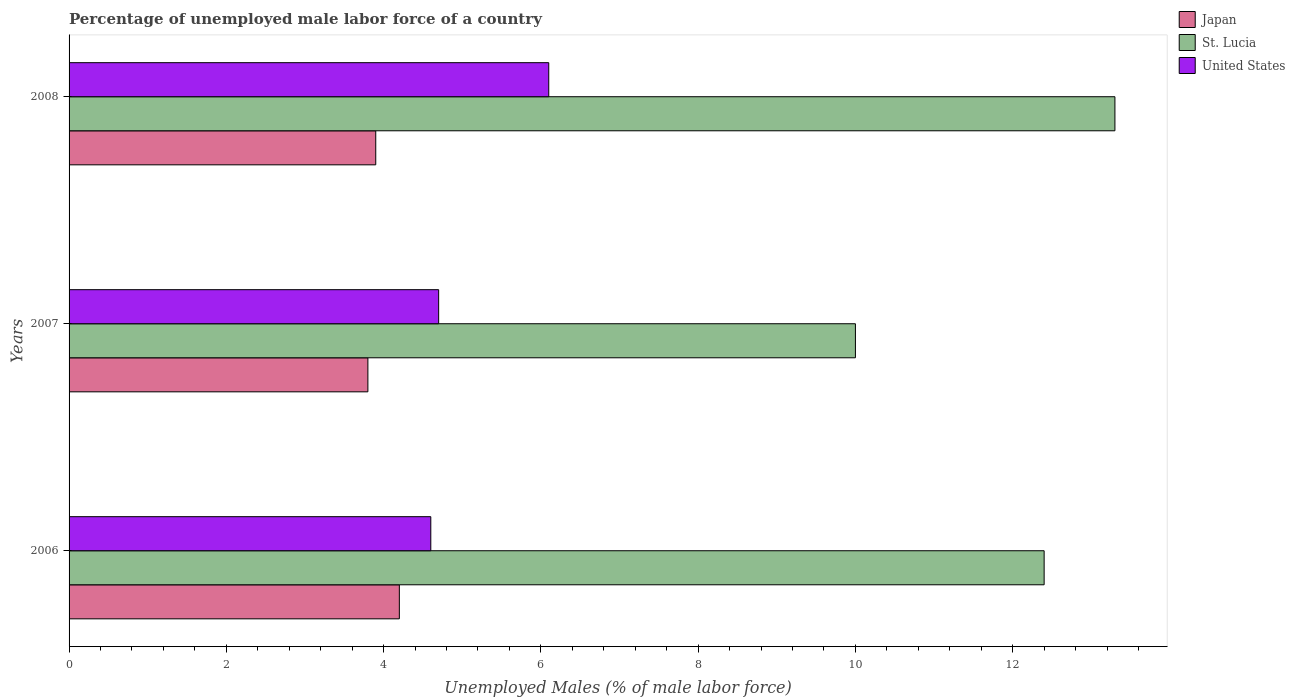How many different coloured bars are there?
Your response must be concise. 3. How many groups of bars are there?
Give a very brief answer. 3. Are the number of bars per tick equal to the number of legend labels?
Ensure brevity in your answer.  Yes. How many bars are there on the 2nd tick from the top?
Keep it short and to the point. 3. How many bars are there on the 2nd tick from the bottom?
Offer a very short reply. 3. What is the label of the 3rd group of bars from the top?
Keep it short and to the point. 2006. In how many cases, is the number of bars for a given year not equal to the number of legend labels?
Your answer should be compact. 0. Across all years, what is the maximum percentage of unemployed male labor force in Japan?
Ensure brevity in your answer.  4.2. Across all years, what is the minimum percentage of unemployed male labor force in United States?
Provide a succinct answer. 4.6. What is the total percentage of unemployed male labor force in United States in the graph?
Make the answer very short. 15.4. What is the difference between the percentage of unemployed male labor force in St. Lucia in 2007 and that in 2008?
Your response must be concise. -3.3. What is the difference between the percentage of unemployed male labor force in United States in 2006 and the percentage of unemployed male labor force in St. Lucia in 2007?
Offer a terse response. -5.4. What is the average percentage of unemployed male labor force in St. Lucia per year?
Provide a succinct answer. 11.9. In the year 2008, what is the difference between the percentage of unemployed male labor force in St. Lucia and percentage of unemployed male labor force in United States?
Your answer should be very brief. 7.2. What is the ratio of the percentage of unemployed male labor force in Japan in 2006 to that in 2008?
Provide a short and direct response. 1.08. What is the difference between the highest and the second highest percentage of unemployed male labor force in Japan?
Ensure brevity in your answer.  0.3. What is the difference between the highest and the lowest percentage of unemployed male labor force in St. Lucia?
Give a very brief answer. 3.3. In how many years, is the percentage of unemployed male labor force in St. Lucia greater than the average percentage of unemployed male labor force in St. Lucia taken over all years?
Ensure brevity in your answer.  2. What does the 2nd bar from the top in 2008 represents?
Make the answer very short. St. Lucia. What does the 1st bar from the bottom in 2006 represents?
Your answer should be very brief. Japan. Is it the case that in every year, the sum of the percentage of unemployed male labor force in Japan and percentage of unemployed male labor force in United States is greater than the percentage of unemployed male labor force in St. Lucia?
Your answer should be very brief. No. How many years are there in the graph?
Your response must be concise. 3. Are the values on the major ticks of X-axis written in scientific E-notation?
Offer a terse response. No. Does the graph contain any zero values?
Give a very brief answer. No. Where does the legend appear in the graph?
Offer a terse response. Top right. How many legend labels are there?
Your response must be concise. 3. What is the title of the graph?
Keep it short and to the point. Percentage of unemployed male labor force of a country. Does "Israel" appear as one of the legend labels in the graph?
Ensure brevity in your answer.  No. What is the label or title of the X-axis?
Make the answer very short. Unemployed Males (% of male labor force). What is the Unemployed Males (% of male labor force) of Japan in 2006?
Offer a very short reply. 4.2. What is the Unemployed Males (% of male labor force) in St. Lucia in 2006?
Provide a succinct answer. 12.4. What is the Unemployed Males (% of male labor force) in United States in 2006?
Provide a succinct answer. 4.6. What is the Unemployed Males (% of male labor force) of Japan in 2007?
Offer a terse response. 3.8. What is the Unemployed Males (% of male labor force) in St. Lucia in 2007?
Your answer should be compact. 10. What is the Unemployed Males (% of male labor force) of United States in 2007?
Provide a succinct answer. 4.7. What is the Unemployed Males (% of male labor force) of Japan in 2008?
Provide a short and direct response. 3.9. What is the Unemployed Males (% of male labor force) of St. Lucia in 2008?
Your answer should be very brief. 13.3. What is the Unemployed Males (% of male labor force) in United States in 2008?
Give a very brief answer. 6.1. Across all years, what is the maximum Unemployed Males (% of male labor force) of Japan?
Ensure brevity in your answer.  4.2. Across all years, what is the maximum Unemployed Males (% of male labor force) in St. Lucia?
Provide a succinct answer. 13.3. Across all years, what is the maximum Unemployed Males (% of male labor force) in United States?
Provide a succinct answer. 6.1. Across all years, what is the minimum Unemployed Males (% of male labor force) of Japan?
Make the answer very short. 3.8. Across all years, what is the minimum Unemployed Males (% of male labor force) of United States?
Give a very brief answer. 4.6. What is the total Unemployed Males (% of male labor force) of Japan in the graph?
Ensure brevity in your answer.  11.9. What is the total Unemployed Males (% of male labor force) of St. Lucia in the graph?
Your response must be concise. 35.7. What is the difference between the Unemployed Males (% of male labor force) of St. Lucia in 2006 and that in 2007?
Your answer should be compact. 2.4. What is the difference between the Unemployed Males (% of male labor force) in Japan in 2006 and that in 2008?
Your response must be concise. 0.3. What is the difference between the Unemployed Males (% of male labor force) of St. Lucia in 2007 and that in 2008?
Your answer should be compact. -3.3. What is the difference between the Unemployed Males (% of male labor force) of United States in 2007 and that in 2008?
Give a very brief answer. -1.4. What is the difference between the Unemployed Males (% of male labor force) in Japan in 2006 and the Unemployed Males (% of male labor force) in St. Lucia in 2008?
Your response must be concise. -9.1. What is the difference between the Unemployed Males (% of male labor force) of St. Lucia in 2006 and the Unemployed Males (% of male labor force) of United States in 2008?
Give a very brief answer. 6.3. What is the difference between the Unemployed Males (% of male labor force) in Japan in 2007 and the Unemployed Males (% of male labor force) in St. Lucia in 2008?
Make the answer very short. -9.5. What is the difference between the Unemployed Males (% of male labor force) in Japan in 2007 and the Unemployed Males (% of male labor force) in United States in 2008?
Your answer should be very brief. -2.3. What is the difference between the Unemployed Males (% of male labor force) in St. Lucia in 2007 and the Unemployed Males (% of male labor force) in United States in 2008?
Offer a very short reply. 3.9. What is the average Unemployed Males (% of male labor force) of Japan per year?
Your answer should be very brief. 3.97. What is the average Unemployed Males (% of male labor force) of St. Lucia per year?
Give a very brief answer. 11.9. What is the average Unemployed Males (% of male labor force) in United States per year?
Provide a short and direct response. 5.13. In the year 2006, what is the difference between the Unemployed Males (% of male labor force) of Japan and Unemployed Males (% of male labor force) of St. Lucia?
Offer a terse response. -8.2. In the year 2006, what is the difference between the Unemployed Males (% of male labor force) of Japan and Unemployed Males (% of male labor force) of United States?
Offer a very short reply. -0.4. In the year 2006, what is the difference between the Unemployed Males (% of male labor force) of St. Lucia and Unemployed Males (% of male labor force) of United States?
Offer a very short reply. 7.8. In the year 2008, what is the difference between the Unemployed Males (% of male labor force) in St. Lucia and Unemployed Males (% of male labor force) in United States?
Provide a short and direct response. 7.2. What is the ratio of the Unemployed Males (% of male labor force) of Japan in 2006 to that in 2007?
Your answer should be compact. 1.11. What is the ratio of the Unemployed Males (% of male labor force) of St. Lucia in 2006 to that in 2007?
Keep it short and to the point. 1.24. What is the ratio of the Unemployed Males (% of male labor force) of United States in 2006 to that in 2007?
Provide a succinct answer. 0.98. What is the ratio of the Unemployed Males (% of male labor force) of St. Lucia in 2006 to that in 2008?
Offer a very short reply. 0.93. What is the ratio of the Unemployed Males (% of male labor force) of United States in 2006 to that in 2008?
Provide a succinct answer. 0.75. What is the ratio of the Unemployed Males (% of male labor force) in Japan in 2007 to that in 2008?
Offer a terse response. 0.97. What is the ratio of the Unemployed Males (% of male labor force) of St. Lucia in 2007 to that in 2008?
Your answer should be very brief. 0.75. What is the ratio of the Unemployed Males (% of male labor force) in United States in 2007 to that in 2008?
Offer a terse response. 0.77. What is the difference between the highest and the second highest Unemployed Males (% of male labor force) of Japan?
Make the answer very short. 0.3. What is the difference between the highest and the second highest Unemployed Males (% of male labor force) of St. Lucia?
Make the answer very short. 0.9. What is the difference between the highest and the second highest Unemployed Males (% of male labor force) in United States?
Ensure brevity in your answer.  1.4. What is the difference between the highest and the lowest Unemployed Males (% of male labor force) of Japan?
Your answer should be compact. 0.4. 